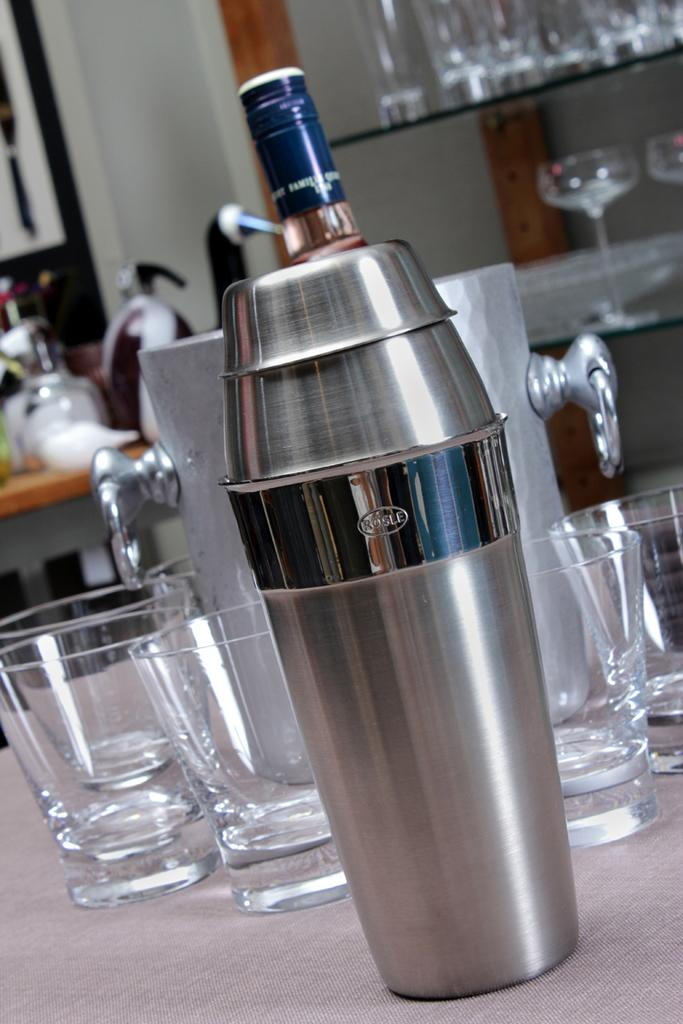<image>
Provide a brief description of the given image. A cocktail shaker with the word Rosle on it sits near some empty glasses. 